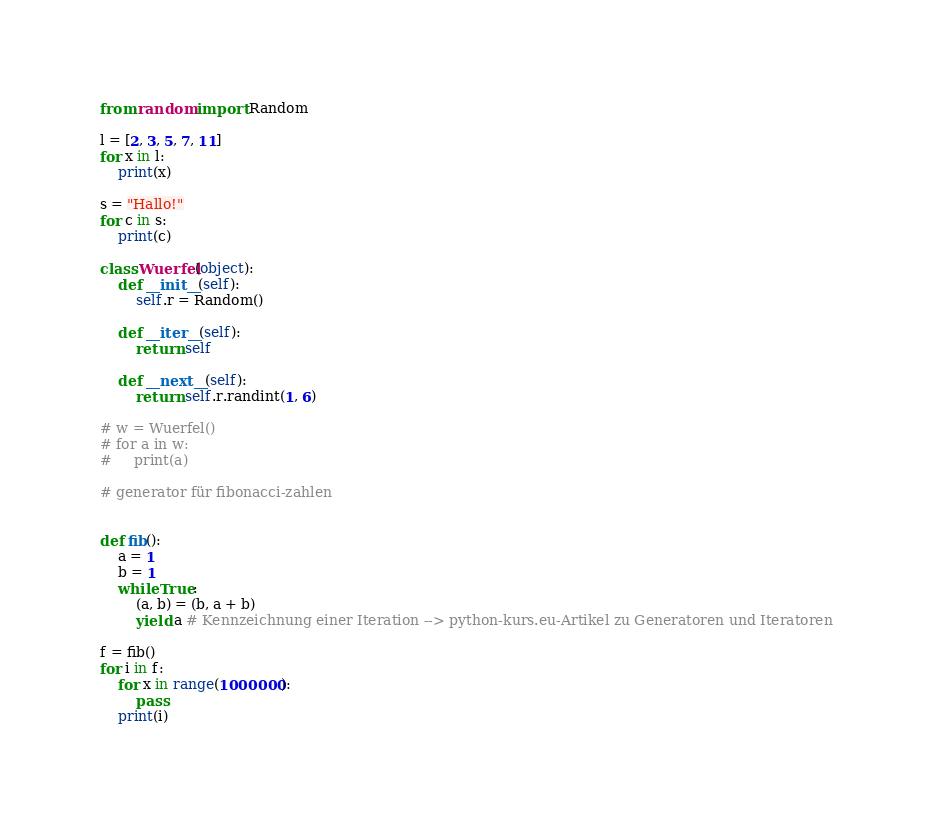Convert code to text. <code><loc_0><loc_0><loc_500><loc_500><_Python_>from random import Random

l = [2, 3, 5, 7, 11]
for x in l:
    print(x)

s = "Hallo!"
for c in s:
    print(c)

class Wuerfel(object):
    def __init__(self):
        self.r = Random()

    def __iter__(self):
        return self

    def __next__(self):
        return self.r.randint(1, 6)

# w = Wuerfel()
# for a in w:
#     print(a)

# generator für fibonacci-zahlen


def fib():
    a = 1
    b = 1
    while True:
        (a, b) = (b, a + b)
        yield a # Kennzeichnung einer Iteration --> python-kurs.eu-Artikel zu Generatoren und Iteratoren

f = fib()
for i in f:
    for x in range(1000000):
        pass
    print(i)

</code> 